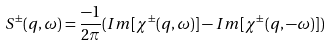<formula> <loc_0><loc_0><loc_500><loc_500>S ^ { \pm } ( q , \omega ) = \frac { - 1 } { 2 \pi } ( I m [ \chi ^ { \pm } ( q , \omega ) ] - I m [ \chi ^ { \pm } ( q , - \omega ) ] )</formula> 